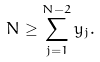<formula> <loc_0><loc_0><loc_500><loc_500>N \geq \sum _ { j = 1 } ^ { N - 2 } y _ { j } .</formula> 